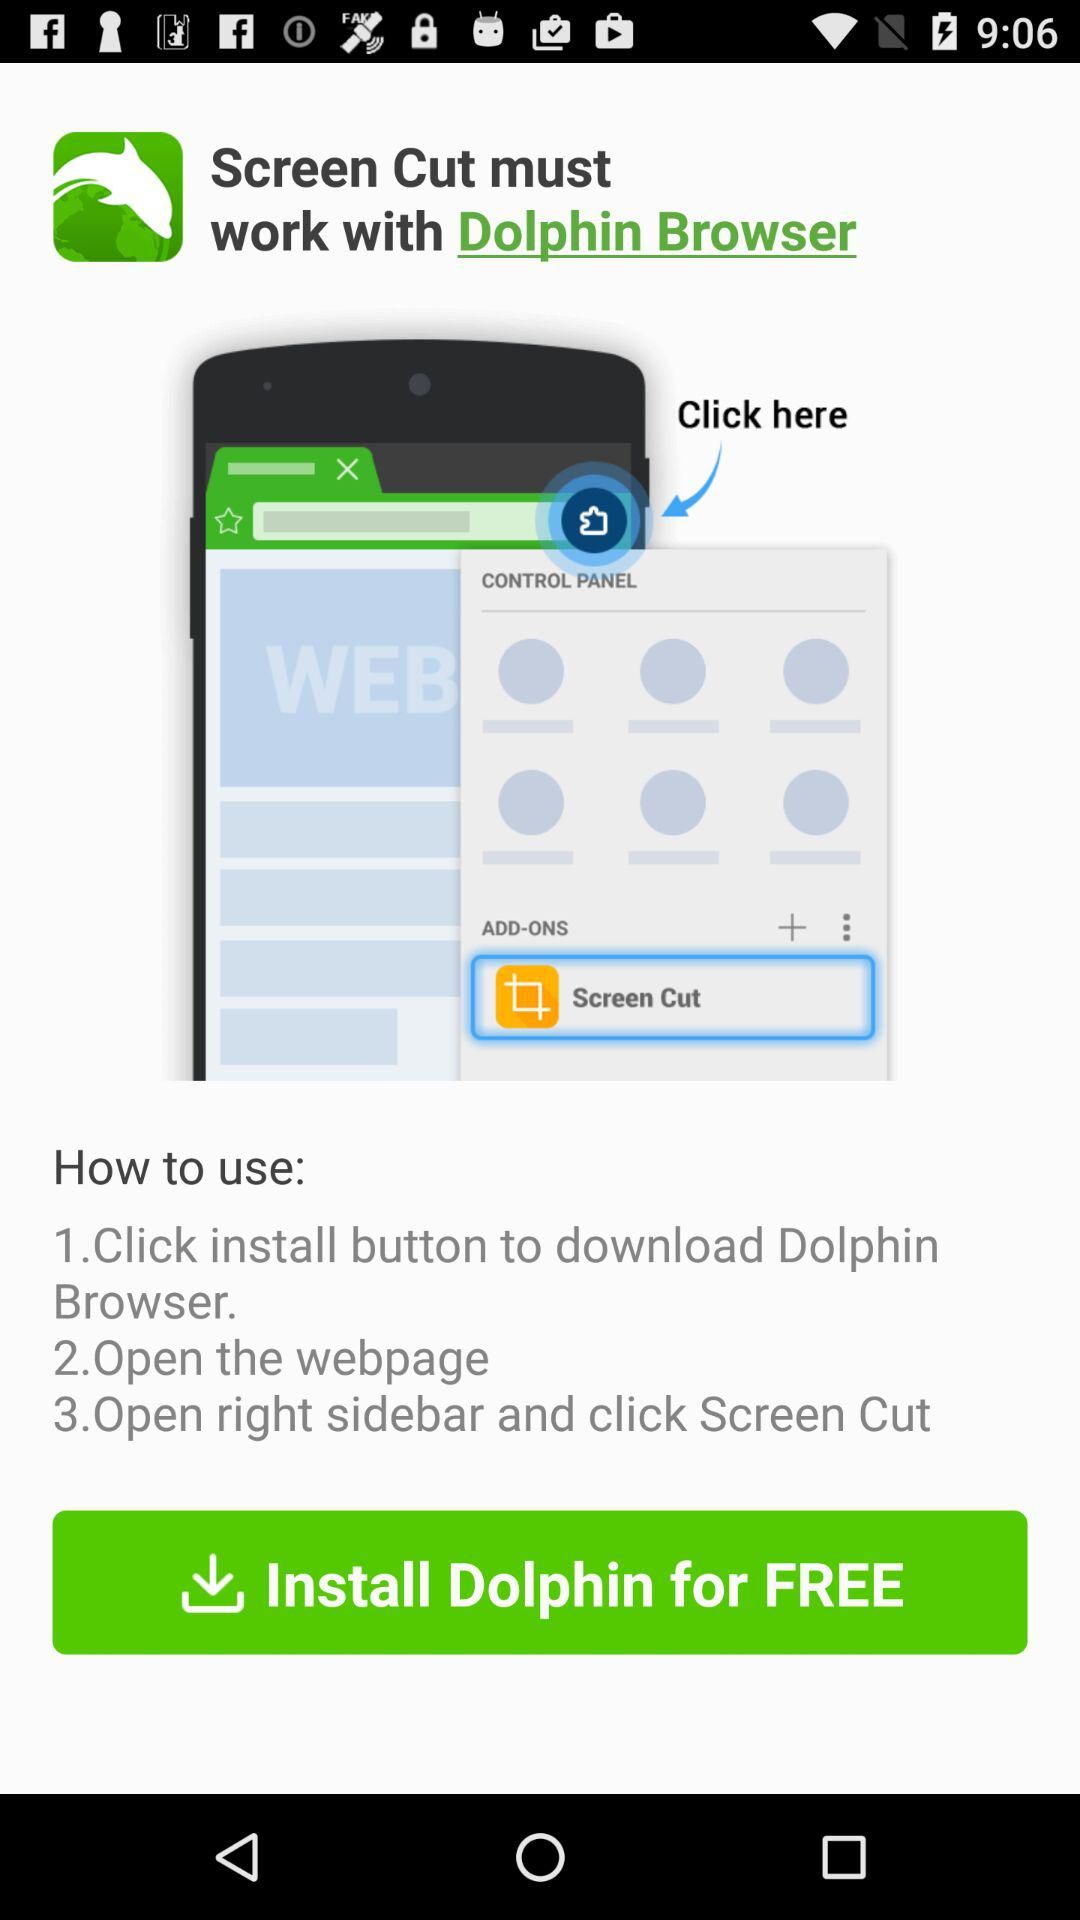How much does "Screen Cut" cost?
When the provided information is insufficient, respond with <no answer>. <no answer> 